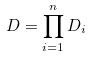<formula> <loc_0><loc_0><loc_500><loc_500>D = \prod _ { i = 1 } ^ { n } D _ { i }</formula> 